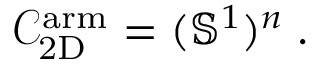<formula> <loc_0><loc_0><loc_500><loc_500>\mathcal { C } _ { 2 D } ^ { a r m } = ( \mathbb { S } ^ { 1 } ) ^ { n } \, .</formula> 